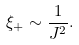Convert formula to latex. <formula><loc_0><loc_0><loc_500><loc_500>\xi _ { + } \sim \frac { 1 } { J ^ { 2 } } .</formula> 